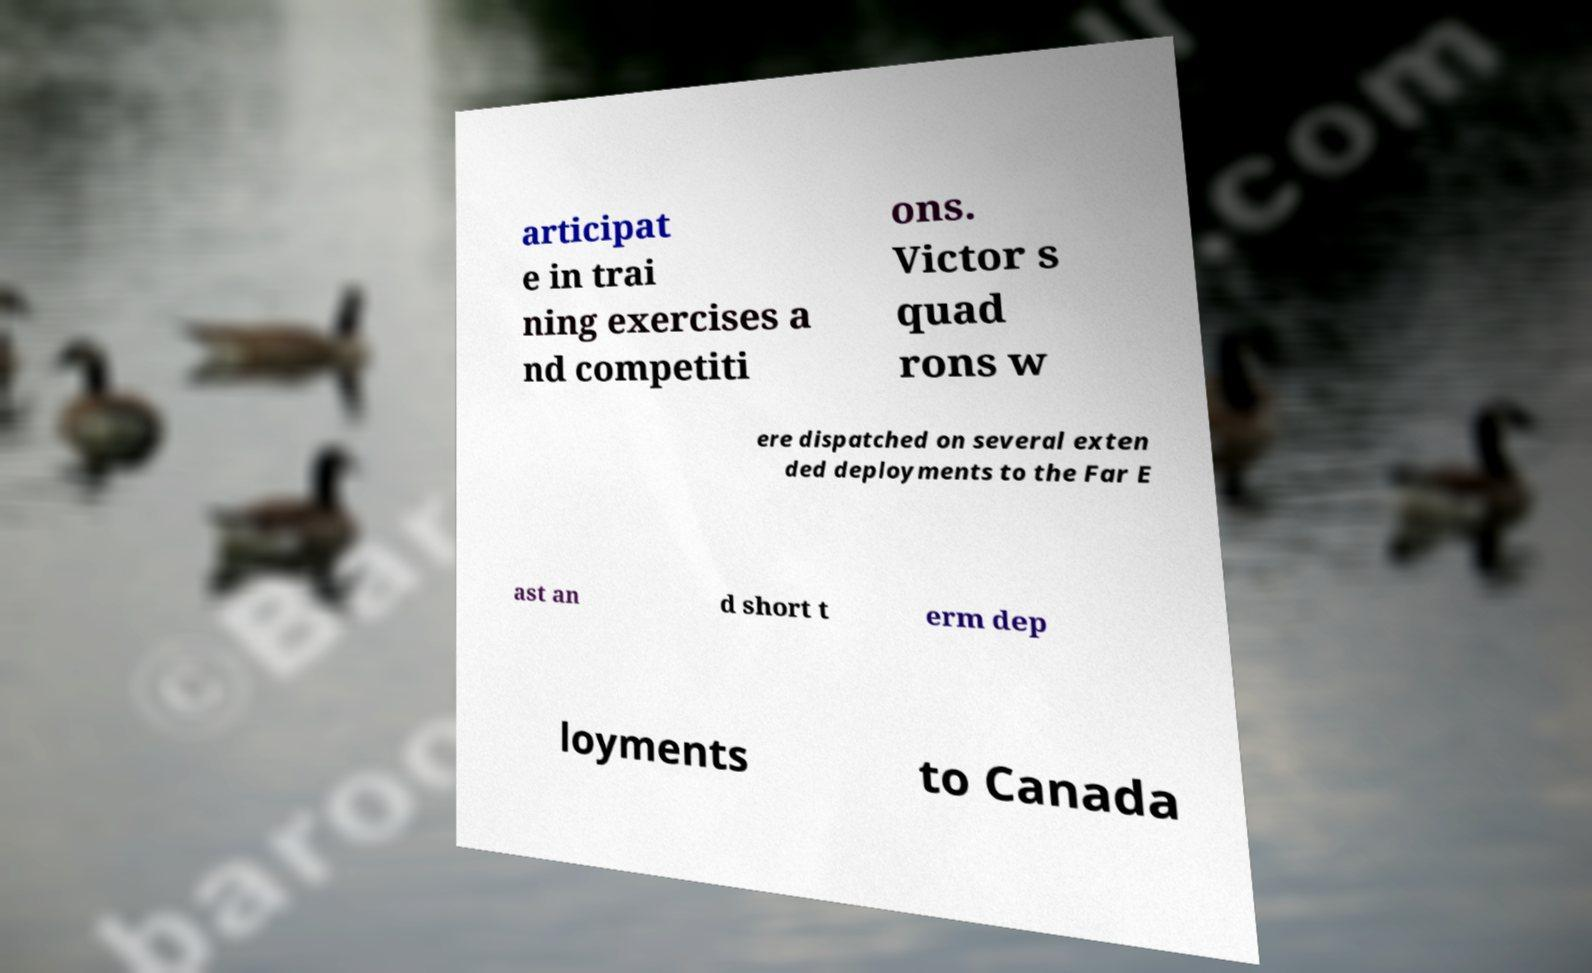Could you extract and type out the text from this image? articipat e in trai ning exercises a nd competiti ons. Victor s quad rons w ere dispatched on several exten ded deployments to the Far E ast an d short t erm dep loyments to Canada 